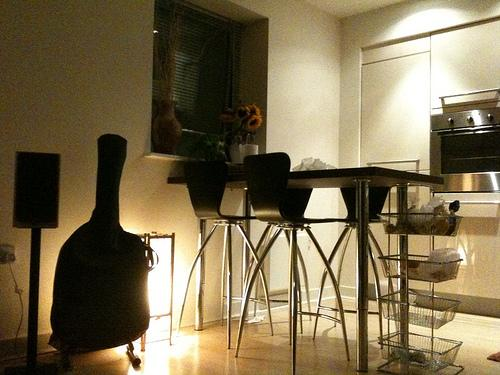What kind of musical instrument is covered by the guitar on the left side of the room? guitar 